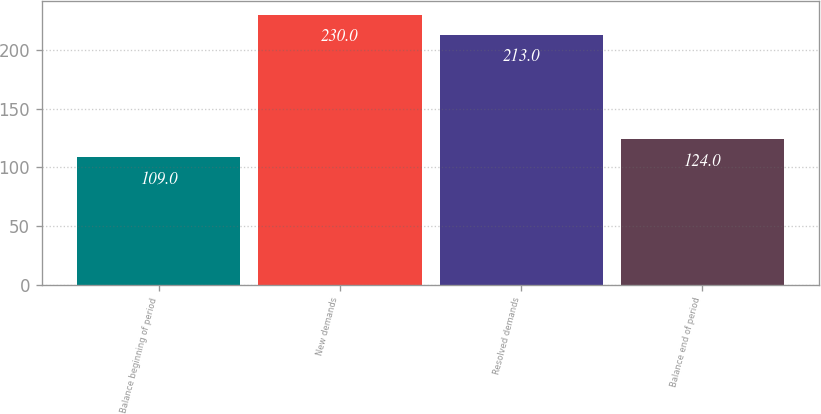<chart> <loc_0><loc_0><loc_500><loc_500><bar_chart><fcel>Balance beginning of period<fcel>New demands<fcel>Resolved demands<fcel>Balance end of period<nl><fcel>109<fcel>230<fcel>213<fcel>124<nl></chart> 